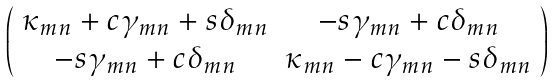Convert formula to latex. <formula><loc_0><loc_0><loc_500><loc_500>\left ( \begin{array} { c c } \kappa _ { m n } + c \gamma _ { m n } + s \delta _ { m n } & - s \gamma _ { m n } + c \delta _ { m n } \\ - s \gamma _ { m n } + c \delta _ { m n } & \kappa _ { m n } - c \gamma _ { m n } - s \delta _ { m n } \end{array} \right )</formula> 